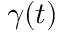Convert formula to latex. <formula><loc_0><loc_0><loc_500><loc_500>\gamma ( t )</formula> 